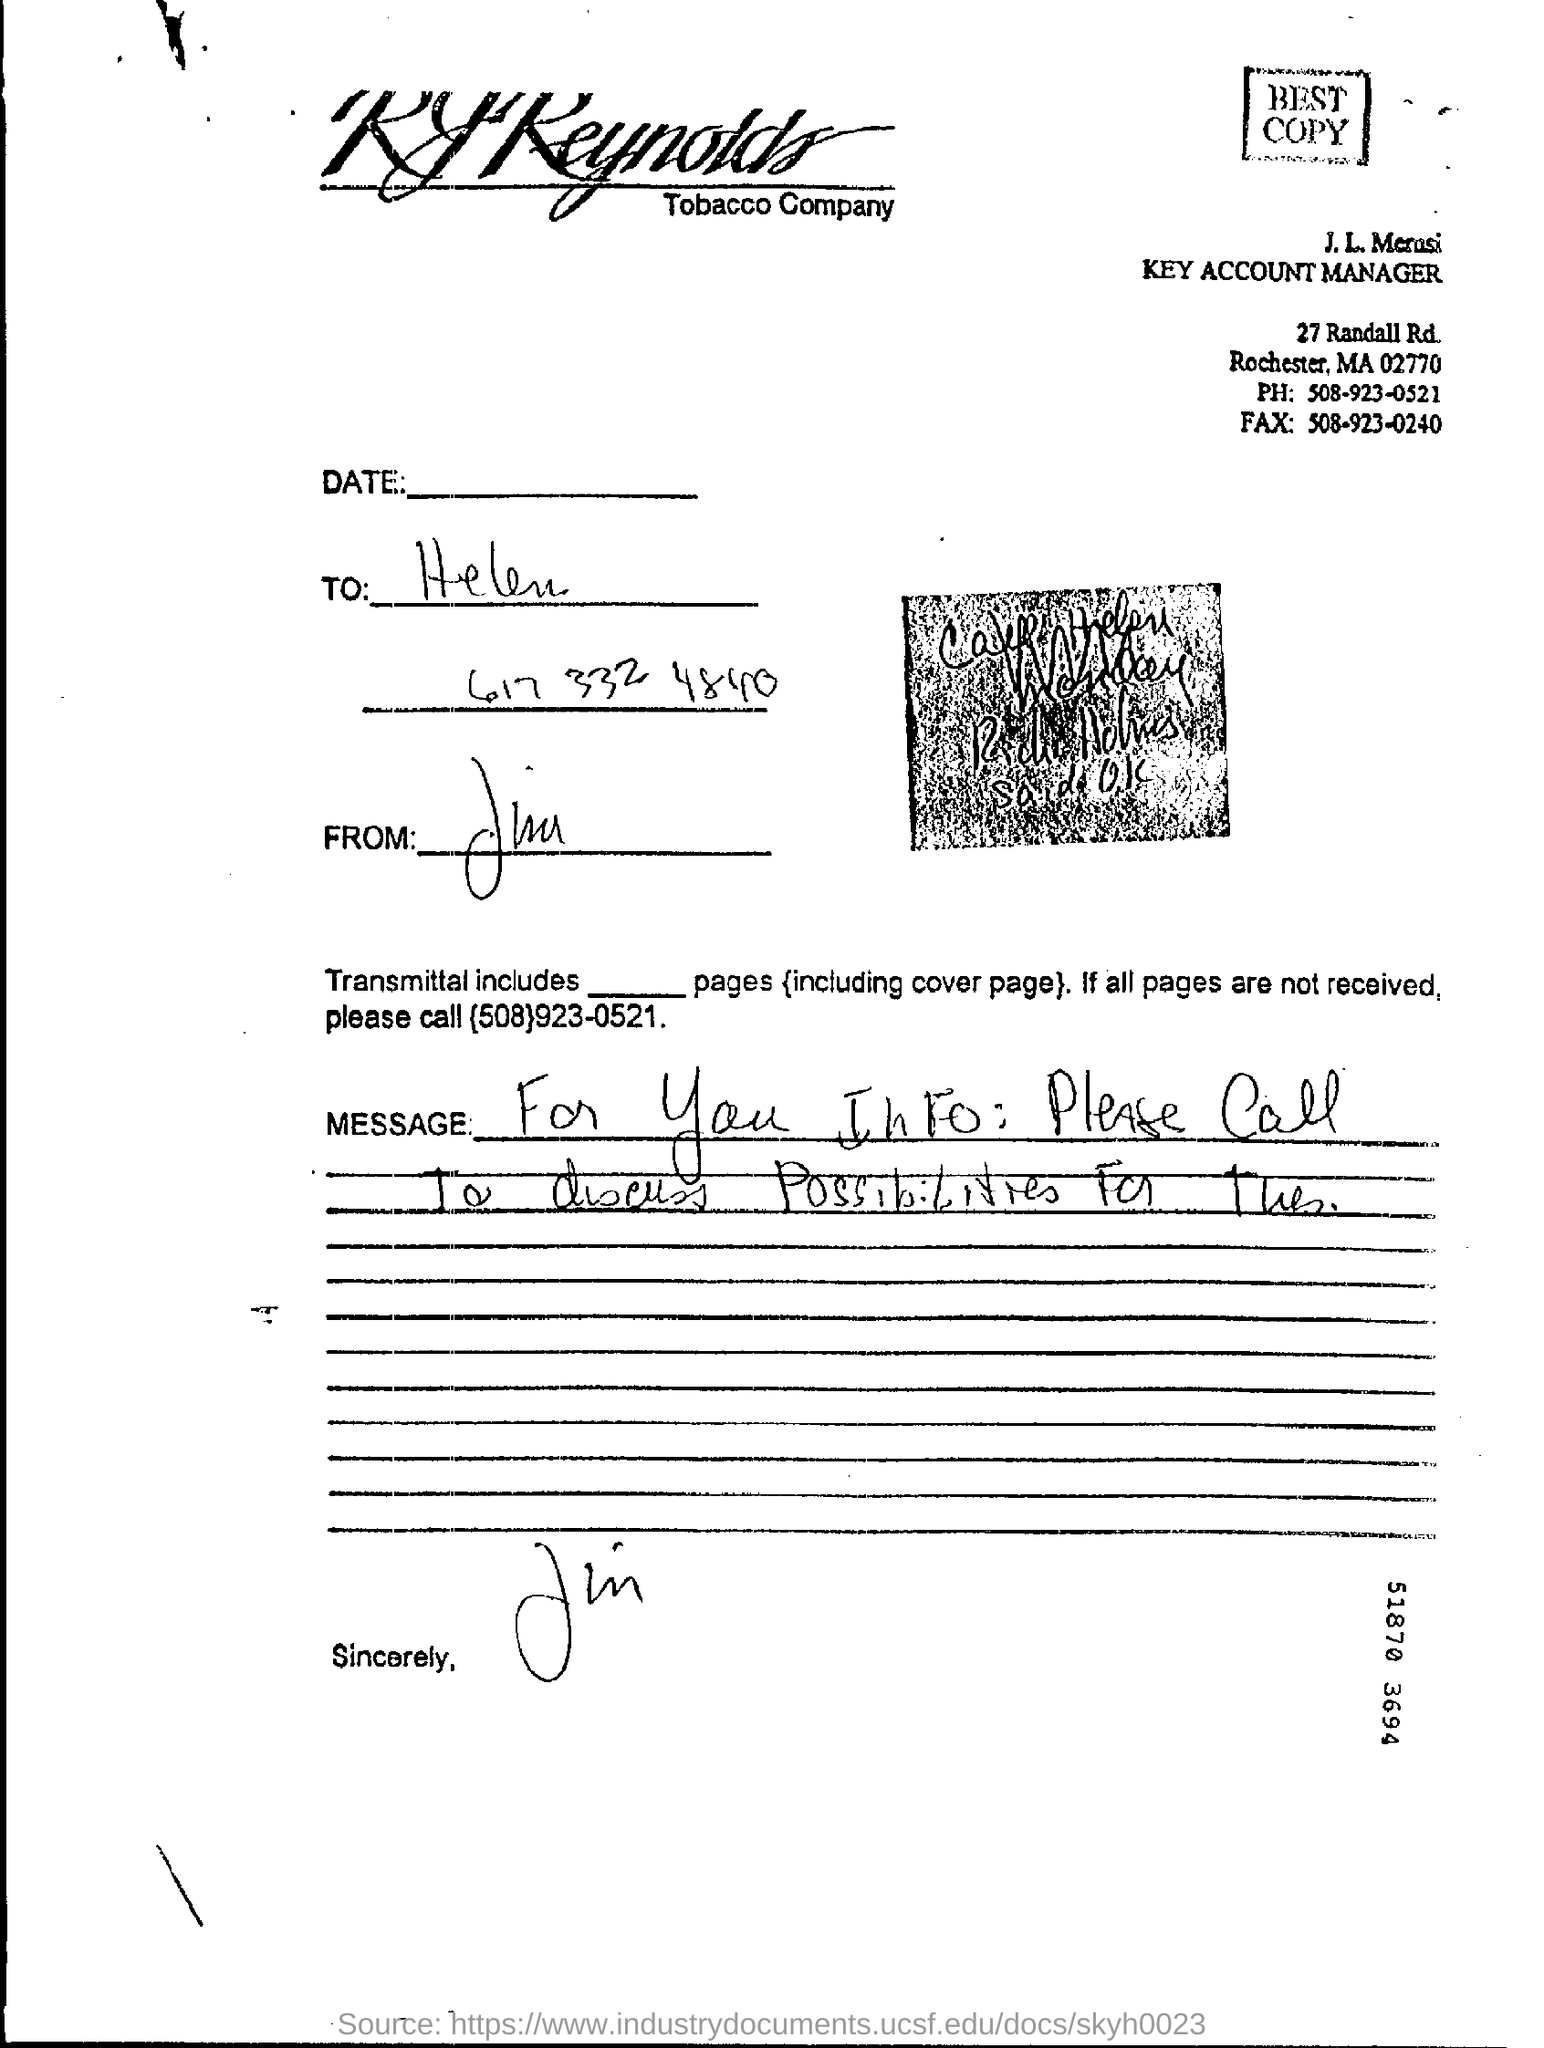What is the name of the company mentioned in the letterhead, and what information can you tell me about it? The letterhead mentions 'R.J. Reynolds Tobacco Company.' This company is one of the largest tobacco manufacturers in the United States, known for various famous brands of cigarettes. The letter suggests business communication, potentially dealing with key account management. 